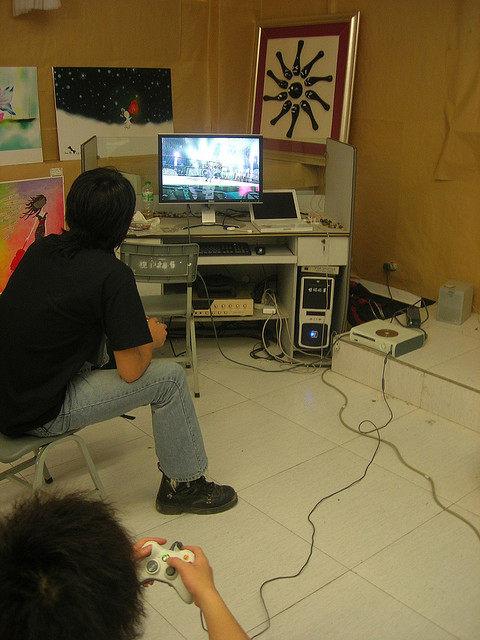Describe the ambiance of the room. The ambiance of the room is a blend of focused activity and creative inspiration. It has a casual yet organized look, predominated by the gaming setup and the array of artistic pieces on the walls. This setting portrays a lively and engaging environment where the occupants can indulge in intense gaming sessions while being surrounded by personal artistic expressions. The convergence of technology and art creates a dynamic and stimulating atmosphere. 